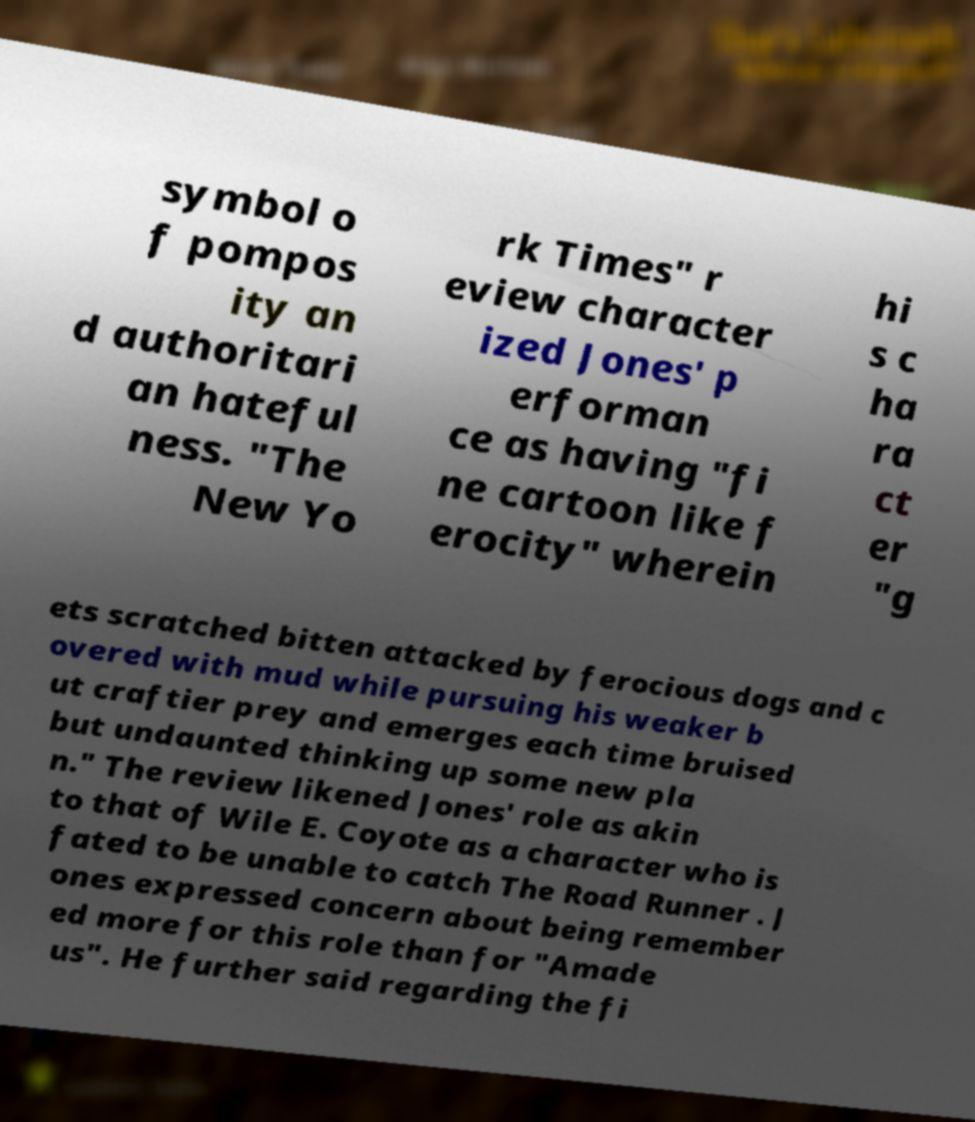I need the written content from this picture converted into text. Can you do that? symbol o f pompos ity an d authoritari an hateful ness. "The New Yo rk Times" r eview character ized Jones' p erforman ce as having "fi ne cartoon like f erocity" wherein hi s c ha ra ct er "g ets scratched bitten attacked by ferocious dogs and c overed with mud while pursuing his weaker b ut craftier prey and emerges each time bruised but undaunted thinking up some new pla n." The review likened Jones' role as akin to that of Wile E. Coyote as a character who is fated to be unable to catch The Road Runner . J ones expressed concern about being remember ed more for this role than for "Amade us". He further said regarding the fi 